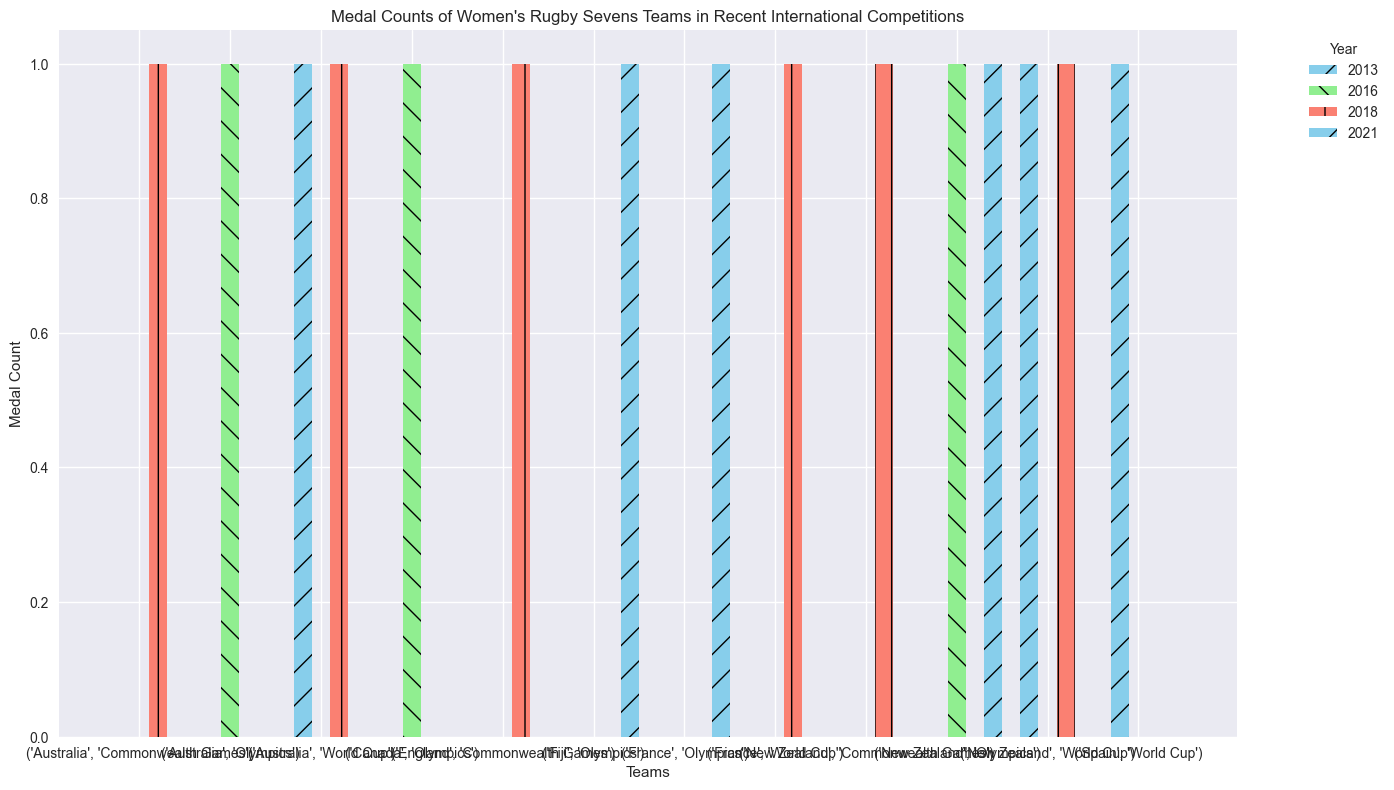Which team won the most medals in the 2016 Olympics? To find the team with the most medals in the 2016 Olympics, observe the bars corresponding to the "Olympics 2016" section. Compare the heights of these bars. New Zealand, Australia, and Canada each have one medal.
Answer: New Zealand, Australia, Canada How many total medals did New Zealand win across all competitions? Count the heights of the bars for New Zealand across all competition sections. New Zealand has medals in 2016 Olympics (1), 2021 Olympics (1), 2013 World Cup (1), 2018 World Cup (1), and 2018 Commonwealth Games (1). Summing them up gives 1 + 1 + 1 + 1 + 1 = 5.
Answer: 5 Which competitions did France win medals in? Check the bars corresponding to France and see which competitions they fall under. France won medals in the 2021 Olympics and the 2018 World Cup.
Answer: 2021 Olympics, 2018 World Cup How does the total number of medals Australia won compare to Spain? Compare the total height of all bars for Australia and Spain. Australia has medals in 2016 Olympics (1), 2013 World Cup (1), and 2018 Commonwealth Games (1), totaling 3. Spain has medals in 2013 World Cup (1). Thus, Australia has more medals than Spain.
Answer: Australia has more than Spain Which team has the least total medals across all competitions? Observe the total height of the bars for each team across all competitions. England and Spain each have one medal, making them the teams with the least total medals.
Answer: England, Spain What is the average number of medals won by teams in the World Cup 2013? Identify the medals won in the 2013 World Cup by observing the bars and sum them: New Zealand (1), Australia (1), Spain (1). The total is 1 + 1 + 1 = 3 medals. There are 3 teams, so the average number of medals is 3/3 = 1.
Answer: 1 Which competition has the highest total medal count? Sum the heights of the bars in each competition section. The Olympics 2016 section has 3 medals, Olympics 2021 has 3, World Cup 2013 has 3, World Cup 2018 has 3, and Commonwealth Games 2018 has 3. Therefore, they all have the same total medal count.
Answer: All competitions have 3 medals each Did England win more medals than Fiji in all competitions? Observe the heights of the bars for England and compare them to Fiji's. England has only one medal in Commonwealth Games 2018, while Fiji has one medal in Olympics 2021. Thus, England did not win more medals overall.
Answer: No 